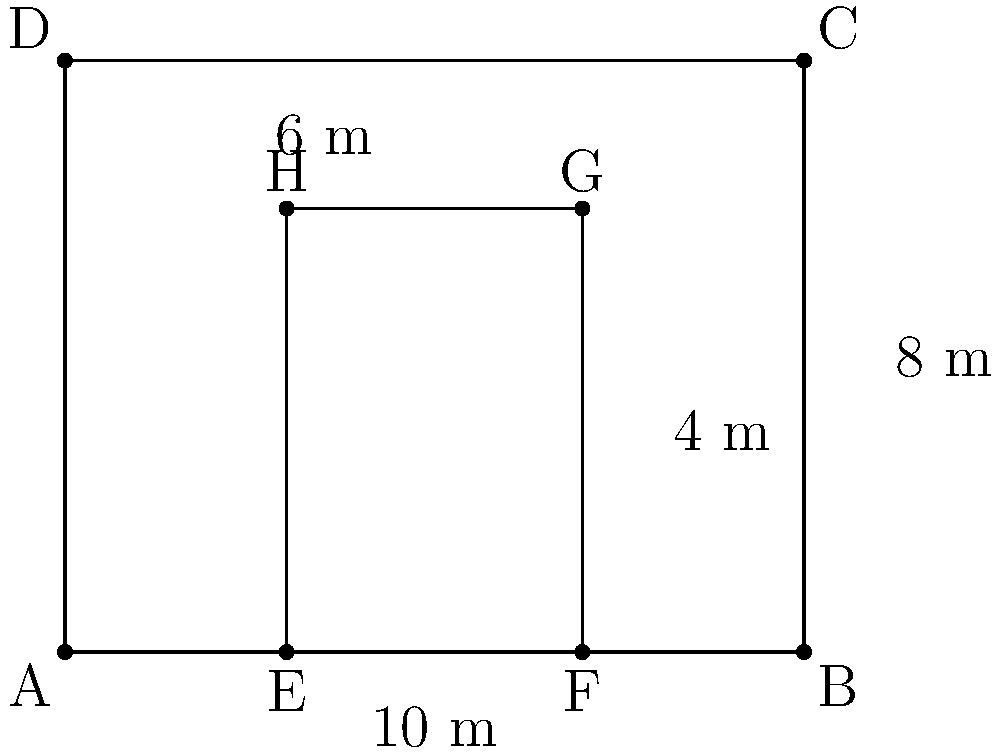In your restaurant, you want to create a VIP seating area. The dining room is rectangular, measuring 10 meters by 8 meters. You decide to section off a smaller rectangular area for VIP seating, leaving a 3-meter border on two sides as shown in the diagram. If each VIP table requires 4 square meters of space, what is the maximum number of VIP tables that can fit in this area? Let's approach this step-by-step:

1) First, we need to calculate the dimensions of the VIP area:
   - Width: $10 - 3 - 3 = 4$ meters
   - Length: $8 - 2 = 6$ meters

2) Now, let's calculate the area of the VIP section:
   $\text{Area} = \text{Width} \times \text{Length} = 4 \text{ m} \times 6 \text{ m} = 24 \text{ m}^2$

3) We're told that each VIP table requires 4 square meters of space.

4) To find the maximum number of tables, we divide the total area by the space required per table:

   $\text{Number of tables} = \frac{\text{Total Area}}{\text{Area per table}} = \frac{24 \text{ m}^2}{4 \text{ m}^2} = 6$

Therefore, the maximum number of VIP tables that can fit in this area is 6.
Answer: 6 tables 